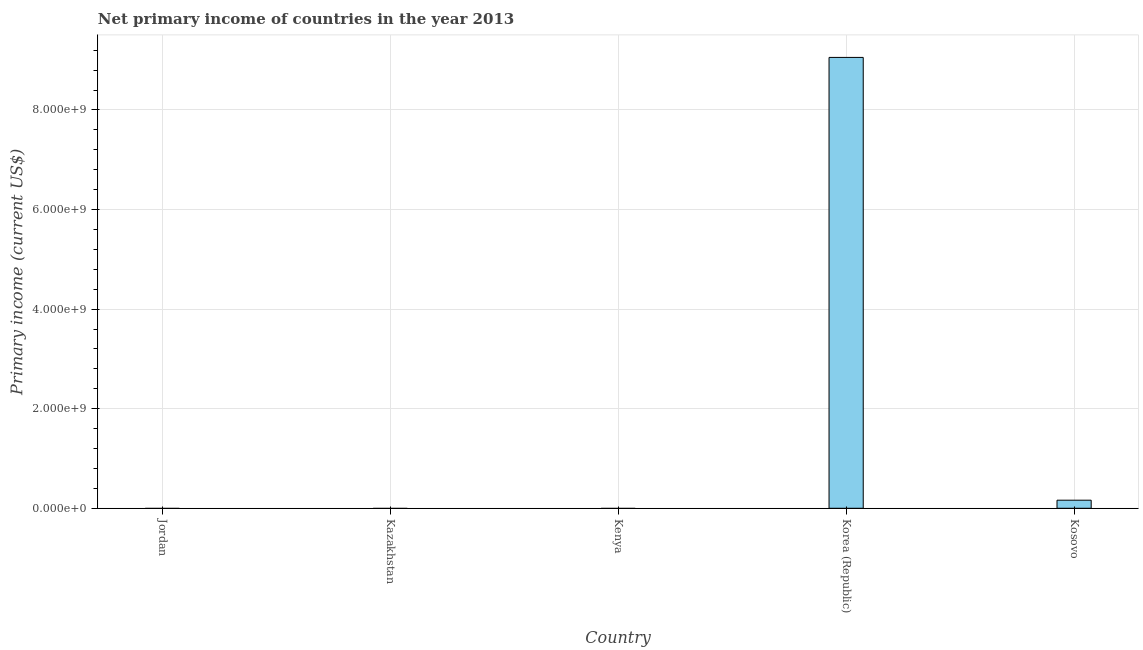Does the graph contain any zero values?
Provide a succinct answer. Yes. Does the graph contain grids?
Offer a terse response. Yes. What is the title of the graph?
Provide a succinct answer. Net primary income of countries in the year 2013. What is the label or title of the Y-axis?
Offer a terse response. Primary income (current US$). Across all countries, what is the maximum amount of primary income?
Offer a very short reply. 9.06e+09. What is the sum of the amount of primary income?
Your response must be concise. 9.22e+09. What is the difference between the amount of primary income in Korea (Republic) and Kosovo?
Your answer should be compact. 8.89e+09. What is the average amount of primary income per country?
Make the answer very short. 1.84e+09. What is the median amount of primary income?
Make the answer very short. 0. What is the ratio of the amount of primary income in Korea (Republic) to that in Kosovo?
Provide a succinct answer. 55.86. Is the sum of the amount of primary income in Korea (Republic) and Kosovo greater than the maximum amount of primary income across all countries?
Your answer should be compact. Yes. What is the difference between the highest and the lowest amount of primary income?
Keep it short and to the point. 9.06e+09. What is the Primary income (current US$) of Korea (Republic)?
Ensure brevity in your answer.  9.06e+09. What is the Primary income (current US$) in Kosovo?
Your answer should be very brief. 1.62e+08. What is the difference between the Primary income (current US$) in Korea (Republic) and Kosovo?
Offer a very short reply. 8.89e+09. What is the ratio of the Primary income (current US$) in Korea (Republic) to that in Kosovo?
Provide a succinct answer. 55.86. 